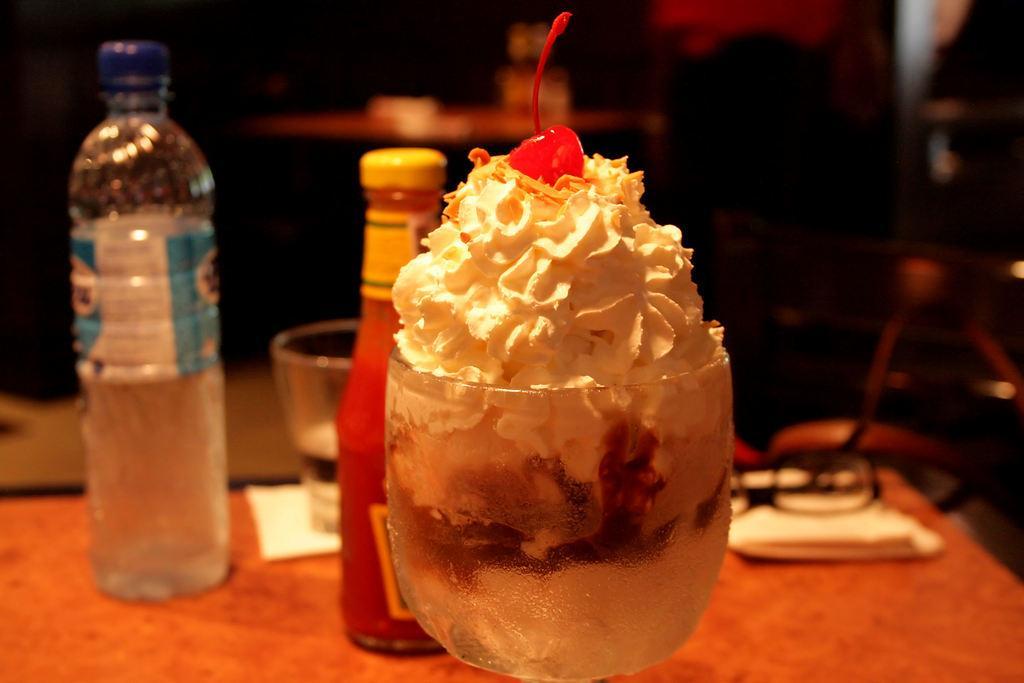Please provide a concise description of this image. This is an ice cream with cherry topping on it. This is a water bottle,tumbler and a ketchup bottle placed on the table. This looks like a spectacles. 